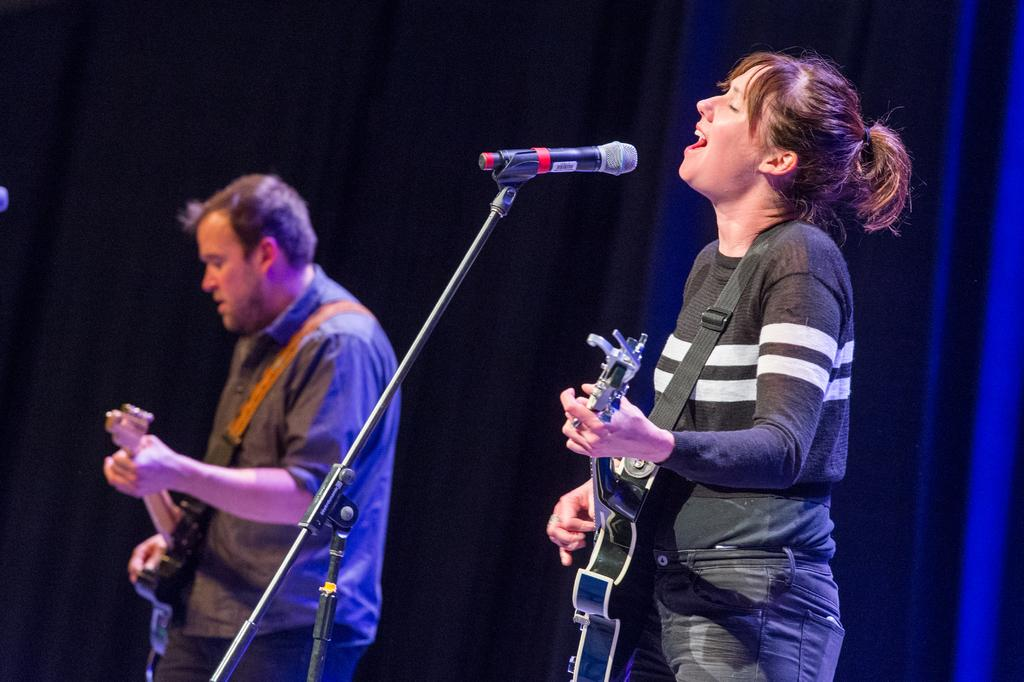What is the woman in the image doing? The woman is holding a guitar and singing into a microphone. What is the man in the image doing? The man is holding a guitar. What can be seen in the background of the image? There is a blue curtain in the background of the image. What route is the advertisement committee taking in the image? There is no advertisement committee or route present in the image. 